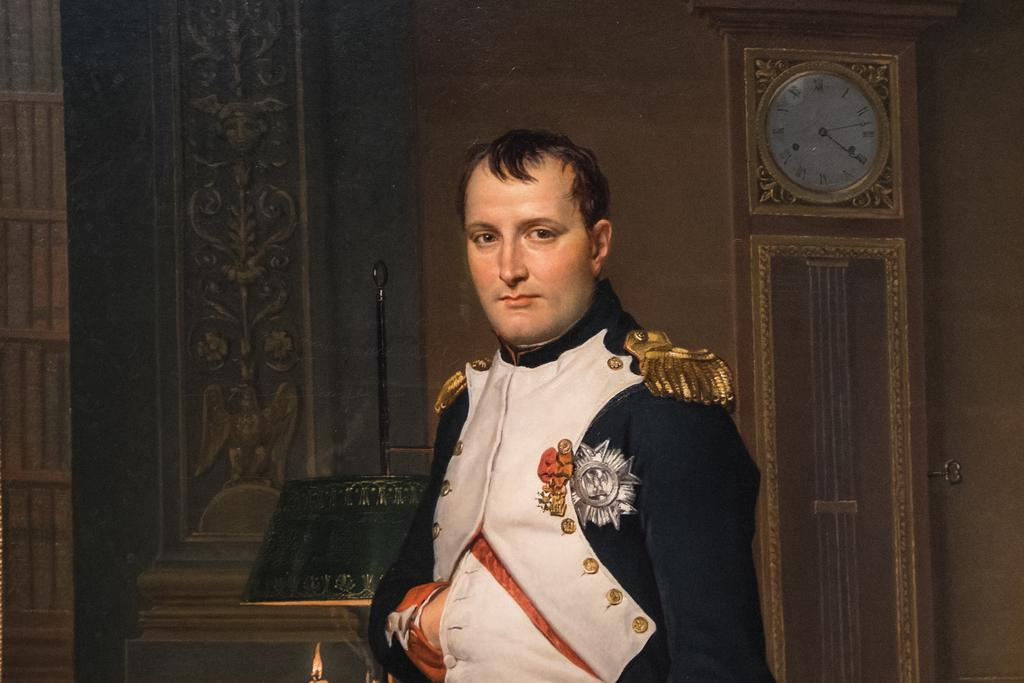What is present in the image? There is a person in the image. Can you describe any objects in the background of the image? There is a clock on the wall in the background of the image. How many turkeys can be seen in the image? There are no turkeys present in the image. What color is the zebra in the image? There is no zebra present in the image. 